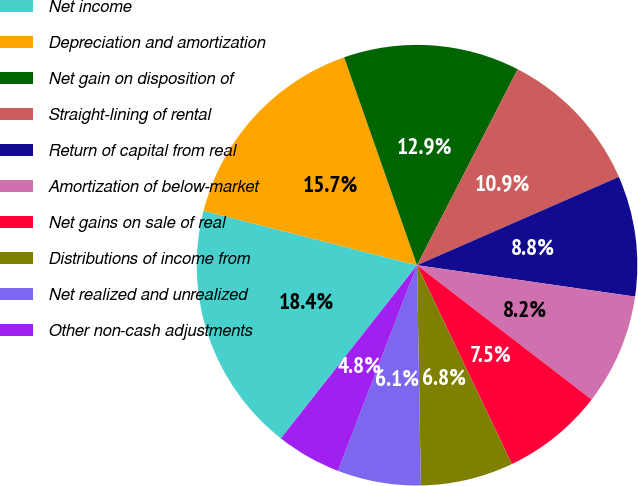<chart> <loc_0><loc_0><loc_500><loc_500><pie_chart><fcel>Net income<fcel>Depreciation and amortization<fcel>Net gain on disposition of<fcel>Straight-lining of rental<fcel>Return of capital from real<fcel>Amortization of below-market<fcel>Net gains on sale of real<fcel>Distributions of income from<fcel>Net realized and unrealized<fcel>Other non-cash adjustments<nl><fcel>18.37%<fcel>15.65%<fcel>12.92%<fcel>10.88%<fcel>8.84%<fcel>8.16%<fcel>7.48%<fcel>6.8%<fcel>6.12%<fcel>4.76%<nl></chart> 